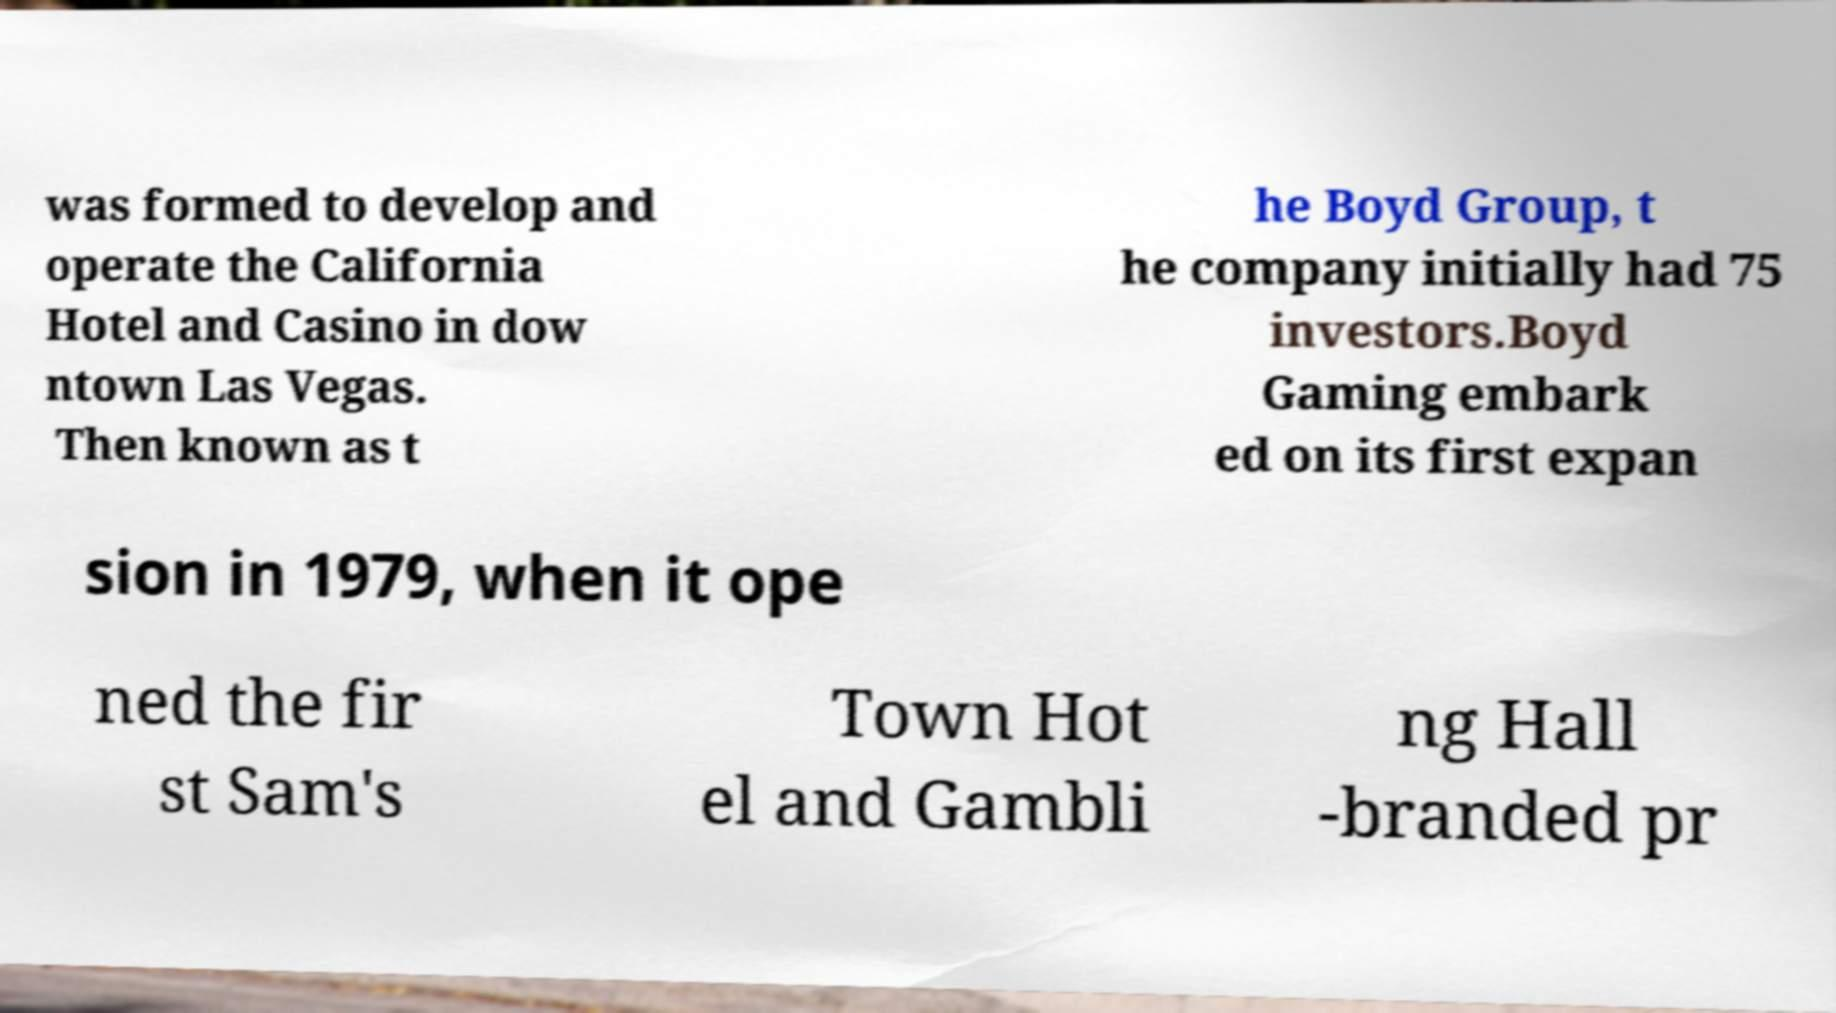For documentation purposes, I need the text within this image transcribed. Could you provide that? was formed to develop and operate the California Hotel and Casino in dow ntown Las Vegas. Then known as t he Boyd Group, t he company initially had 75 investors.Boyd Gaming embark ed on its first expan sion in 1979, when it ope ned the fir st Sam's Town Hot el and Gambli ng Hall -branded pr 